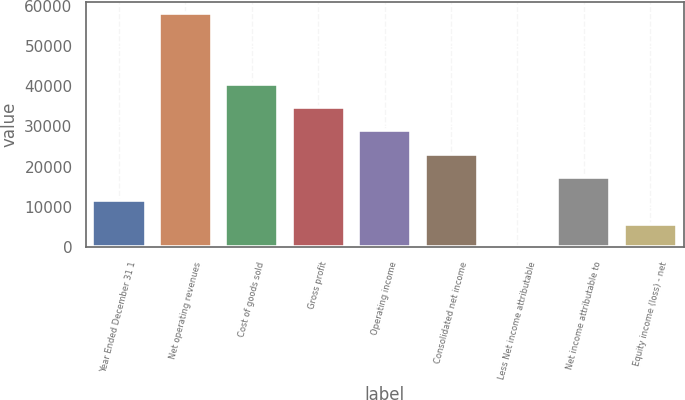<chart> <loc_0><loc_0><loc_500><loc_500><bar_chart><fcel>Year Ended December 31 1<fcel>Net operating revenues<fcel>Cost of goods sold<fcel>Gross profit<fcel>Operating income<fcel>Consolidated net income<fcel>Less Net income attributable<fcel>Net income attributable to<fcel>Equity income (loss) - net<nl><fcel>11673.2<fcel>58054<fcel>40661.2<fcel>34863.6<fcel>29066<fcel>23268.4<fcel>78<fcel>17470.8<fcel>5875.6<nl></chart> 